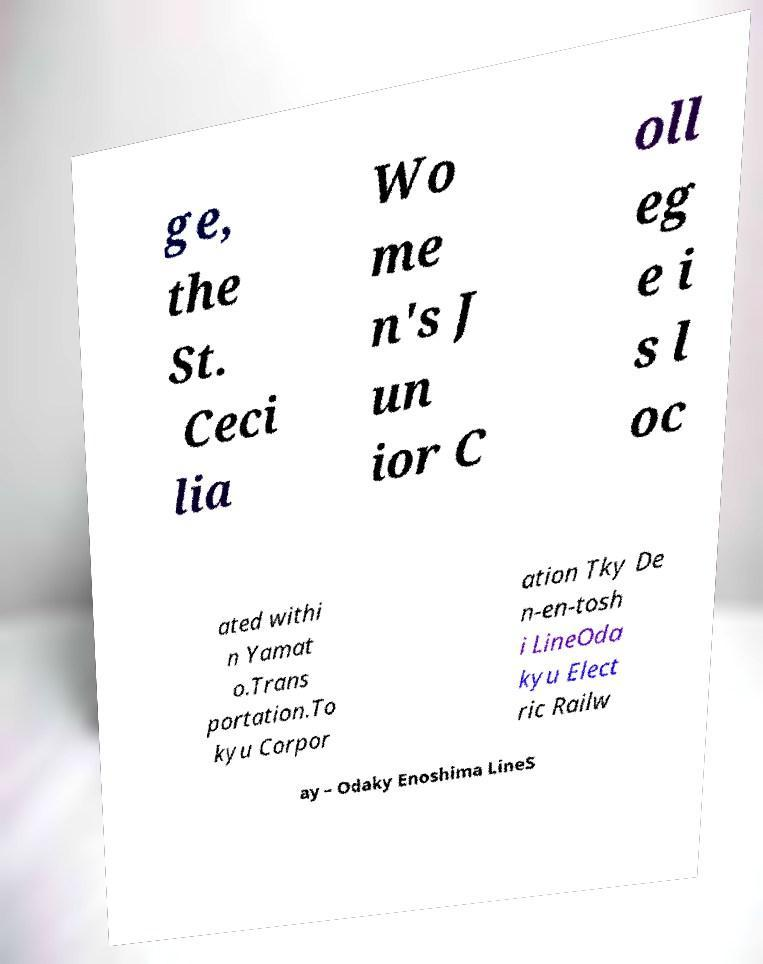Please identify and transcribe the text found in this image. ge, the St. Ceci lia Wo me n's J un ior C oll eg e i s l oc ated withi n Yamat o.Trans portation.To kyu Corpor ation Tky De n-en-tosh i LineOda kyu Elect ric Railw ay – Odaky Enoshima LineS 